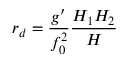<formula> <loc_0><loc_0><loc_500><loc_500>r _ { d } = \frac { g ^ { \prime } } { f _ { 0 } ^ { 2 } } \frac { H _ { 1 } H _ { 2 } } { H }</formula> 